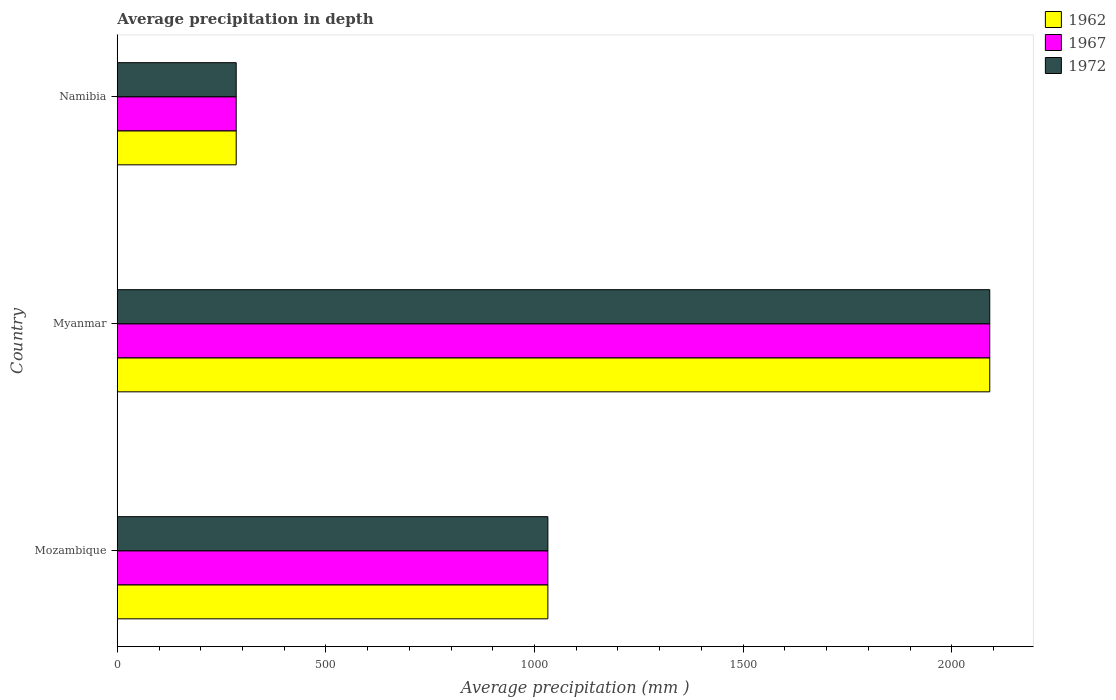How many groups of bars are there?
Your answer should be very brief. 3. Are the number of bars per tick equal to the number of legend labels?
Offer a terse response. Yes. How many bars are there on the 3rd tick from the top?
Keep it short and to the point. 3. What is the label of the 1st group of bars from the top?
Your response must be concise. Namibia. What is the average precipitation in 1962 in Namibia?
Offer a terse response. 285. Across all countries, what is the maximum average precipitation in 1972?
Your answer should be very brief. 2091. Across all countries, what is the minimum average precipitation in 1972?
Provide a succinct answer. 285. In which country was the average precipitation in 1962 maximum?
Your response must be concise. Myanmar. In which country was the average precipitation in 1967 minimum?
Give a very brief answer. Namibia. What is the total average precipitation in 1962 in the graph?
Offer a terse response. 3408. What is the difference between the average precipitation in 1972 in Mozambique and that in Myanmar?
Make the answer very short. -1059. What is the difference between the average precipitation in 1962 in Myanmar and the average precipitation in 1967 in Mozambique?
Offer a terse response. 1059. What is the average average precipitation in 1972 per country?
Your response must be concise. 1136. What is the difference between the average precipitation in 1972 and average precipitation in 1967 in Namibia?
Offer a terse response. 0. In how many countries, is the average precipitation in 1967 greater than 2000 mm?
Offer a very short reply. 1. What is the ratio of the average precipitation in 1962 in Mozambique to that in Myanmar?
Give a very brief answer. 0.49. Is the average precipitation in 1972 in Myanmar less than that in Namibia?
Your response must be concise. No. Is the difference between the average precipitation in 1972 in Mozambique and Namibia greater than the difference between the average precipitation in 1967 in Mozambique and Namibia?
Your answer should be very brief. No. What is the difference between the highest and the second highest average precipitation in 1962?
Ensure brevity in your answer.  1059. What is the difference between the highest and the lowest average precipitation in 1972?
Ensure brevity in your answer.  1806. What does the 3rd bar from the bottom in Namibia represents?
Offer a very short reply. 1972. How many bars are there?
Make the answer very short. 9. Are all the bars in the graph horizontal?
Your answer should be compact. Yes. How many countries are there in the graph?
Your response must be concise. 3. What is the difference between two consecutive major ticks on the X-axis?
Make the answer very short. 500. Does the graph contain grids?
Offer a terse response. No. Where does the legend appear in the graph?
Provide a short and direct response. Top right. What is the title of the graph?
Give a very brief answer. Average precipitation in depth. Does "2004" appear as one of the legend labels in the graph?
Offer a very short reply. No. What is the label or title of the X-axis?
Offer a very short reply. Average precipitation (mm ). What is the Average precipitation (mm ) in 1962 in Mozambique?
Provide a short and direct response. 1032. What is the Average precipitation (mm ) in 1967 in Mozambique?
Give a very brief answer. 1032. What is the Average precipitation (mm ) in 1972 in Mozambique?
Your answer should be compact. 1032. What is the Average precipitation (mm ) in 1962 in Myanmar?
Offer a terse response. 2091. What is the Average precipitation (mm ) of 1967 in Myanmar?
Give a very brief answer. 2091. What is the Average precipitation (mm ) in 1972 in Myanmar?
Your answer should be very brief. 2091. What is the Average precipitation (mm ) of 1962 in Namibia?
Your response must be concise. 285. What is the Average precipitation (mm ) of 1967 in Namibia?
Offer a terse response. 285. What is the Average precipitation (mm ) of 1972 in Namibia?
Make the answer very short. 285. Across all countries, what is the maximum Average precipitation (mm ) of 1962?
Make the answer very short. 2091. Across all countries, what is the maximum Average precipitation (mm ) in 1967?
Your answer should be compact. 2091. Across all countries, what is the maximum Average precipitation (mm ) in 1972?
Your answer should be compact. 2091. Across all countries, what is the minimum Average precipitation (mm ) of 1962?
Provide a short and direct response. 285. Across all countries, what is the minimum Average precipitation (mm ) in 1967?
Make the answer very short. 285. Across all countries, what is the minimum Average precipitation (mm ) in 1972?
Give a very brief answer. 285. What is the total Average precipitation (mm ) of 1962 in the graph?
Offer a very short reply. 3408. What is the total Average precipitation (mm ) in 1967 in the graph?
Ensure brevity in your answer.  3408. What is the total Average precipitation (mm ) of 1972 in the graph?
Your answer should be compact. 3408. What is the difference between the Average precipitation (mm ) of 1962 in Mozambique and that in Myanmar?
Your answer should be very brief. -1059. What is the difference between the Average precipitation (mm ) in 1967 in Mozambique and that in Myanmar?
Offer a very short reply. -1059. What is the difference between the Average precipitation (mm ) in 1972 in Mozambique and that in Myanmar?
Your answer should be compact. -1059. What is the difference between the Average precipitation (mm ) in 1962 in Mozambique and that in Namibia?
Provide a short and direct response. 747. What is the difference between the Average precipitation (mm ) in 1967 in Mozambique and that in Namibia?
Offer a very short reply. 747. What is the difference between the Average precipitation (mm ) of 1972 in Mozambique and that in Namibia?
Offer a terse response. 747. What is the difference between the Average precipitation (mm ) of 1962 in Myanmar and that in Namibia?
Give a very brief answer. 1806. What is the difference between the Average precipitation (mm ) of 1967 in Myanmar and that in Namibia?
Make the answer very short. 1806. What is the difference between the Average precipitation (mm ) in 1972 in Myanmar and that in Namibia?
Provide a short and direct response. 1806. What is the difference between the Average precipitation (mm ) in 1962 in Mozambique and the Average precipitation (mm ) in 1967 in Myanmar?
Give a very brief answer. -1059. What is the difference between the Average precipitation (mm ) of 1962 in Mozambique and the Average precipitation (mm ) of 1972 in Myanmar?
Keep it short and to the point. -1059. What is the difference between the Average precipitation (mm ) in 1967 in Mozambique and the Average precipitation (mm ) in 1972 in Myanmar?
Provide a succinct answer. -1059. What is the difference between the Average precipitation (mm ) of 1962 in Mozambique and the Average precipitation (mm ) of 1967 in Namibia?
Make the answer very short. 747. What is the difference between the Average precipitation (mm ) of 1962 in Mozambique and the Average precipitation (mm ) of 1972 in Namibia?
Keep it short and to the point. 747. What is the difference between the Average precipitation (mm ) in 1967 in Mozambique and the Average precipitation (mm ) in 1972 in Namibia?
Offer a terse response. 747. What is the difference between the Average precipitation (mm ) in 1962 in Myanmar and the Average precipitation (mm ) in 1967 in Namibia?
Keep it short and to the point. 1806. What is the difference between the Average precipitation (mm ) in 1962 in Myanmar and the Average precipitation (mm ) in 1972 in Namibia?
Ensure brevity in your answer.  1806. What is the difference between the Average precipitation (mm ) of 1967 in Myanmar and the Average precipitation (mm ) of 1972 in Namibia?
Your answer should be compact. 1806. What is the average Average precipitation (mm ) of 1962 per country?
Provide a short and direct response. 1136. What is the average Average precipitation (mm ) in 1967 per country?
Offer a terse response. 1136. What is the average Average precipitation (mm ) of 1972 per country?
Keep it short and to the point. 1136. What is the difference between the Average precipitation (mm ) of 1962 and Average precipitation (mm ) of 1967 in Mozambique?
Provide a short and direct response. 0. What is the difference between the Average precipitation (mm ) of 1962 and Average precipitation (mm ) of 1972 in Mozambique?
Your answer should be very brief. 0. What is the difference between the Average precipitation (mm ) of 1967 and Average precipitation (mm ) of 1972 in Mozambique?
Give a very brief answer. 0. What is the ratio of the Average precipitation (mm ) in 1962 in Mozambique to that in Myanmar?
Provide a succinct answer. 0.49. What is the ratio of the Average precipitation (mm ) of 1967 in Mozambique to that in Myanmar?
Keep it short and to the point. 0.49. What is the ratio of the Average precipitation (mm ) in 1972 in Mozambique to that in Myanmar?
Offer a very short reply. 0.49. What is the ratio of the Average precipitation (mm ) in 1962 in Mozambique to that in Namibia?
Keep it short and to the point. 3.62. What is the ratio of the Average precipitation (mm ) in 1967 in Mozambique to that in Namibia?
Your answer should be compact. 3.62. What is the ratio of the Average precipitation (mm ) in 1972 in Mozambique to that in Namibia?
Keep it short and to the point. 3.62. What is the ratio of the Average precipitation (mm ) in 1962 in Myanmar to that in Namibia?
Keep it short and to the point. 7.34. What is the ratio of the Average precipitation (mm ) in 1967 in Myanmar to that in Namibia?
Offer a very short reply. 7.34. What is the ratio of the Average precipitation (mm ) of 1972 in Myanmar to that in Namibia?
Offer a very short reply. 7.34. What is the difference between the highest and the second highest Average precipitation (mm ) of 1962?
Offer a very short reply. 1059. What is the difference between the highest and the second highest Average precipitation (mm ) in 1967?
Your answer should be compact. 1059. What is the difference between the highest and the second highest Average precipitation (mm ) in 1972?
Your answer should be very brief. 1059. What is the difference between the highest and the lowest Average precipitation (mm ) in 1962?
Ensure brevity in your answer.  1806. What is the difference between the highest and the lowest Average precipitation (mm ) in 1967?
Give a very brief answer. 1806. What is the difference between the highest and the lowest Average precipitation (mm ) of 1972?
Provide a succinct answer. 1806. 